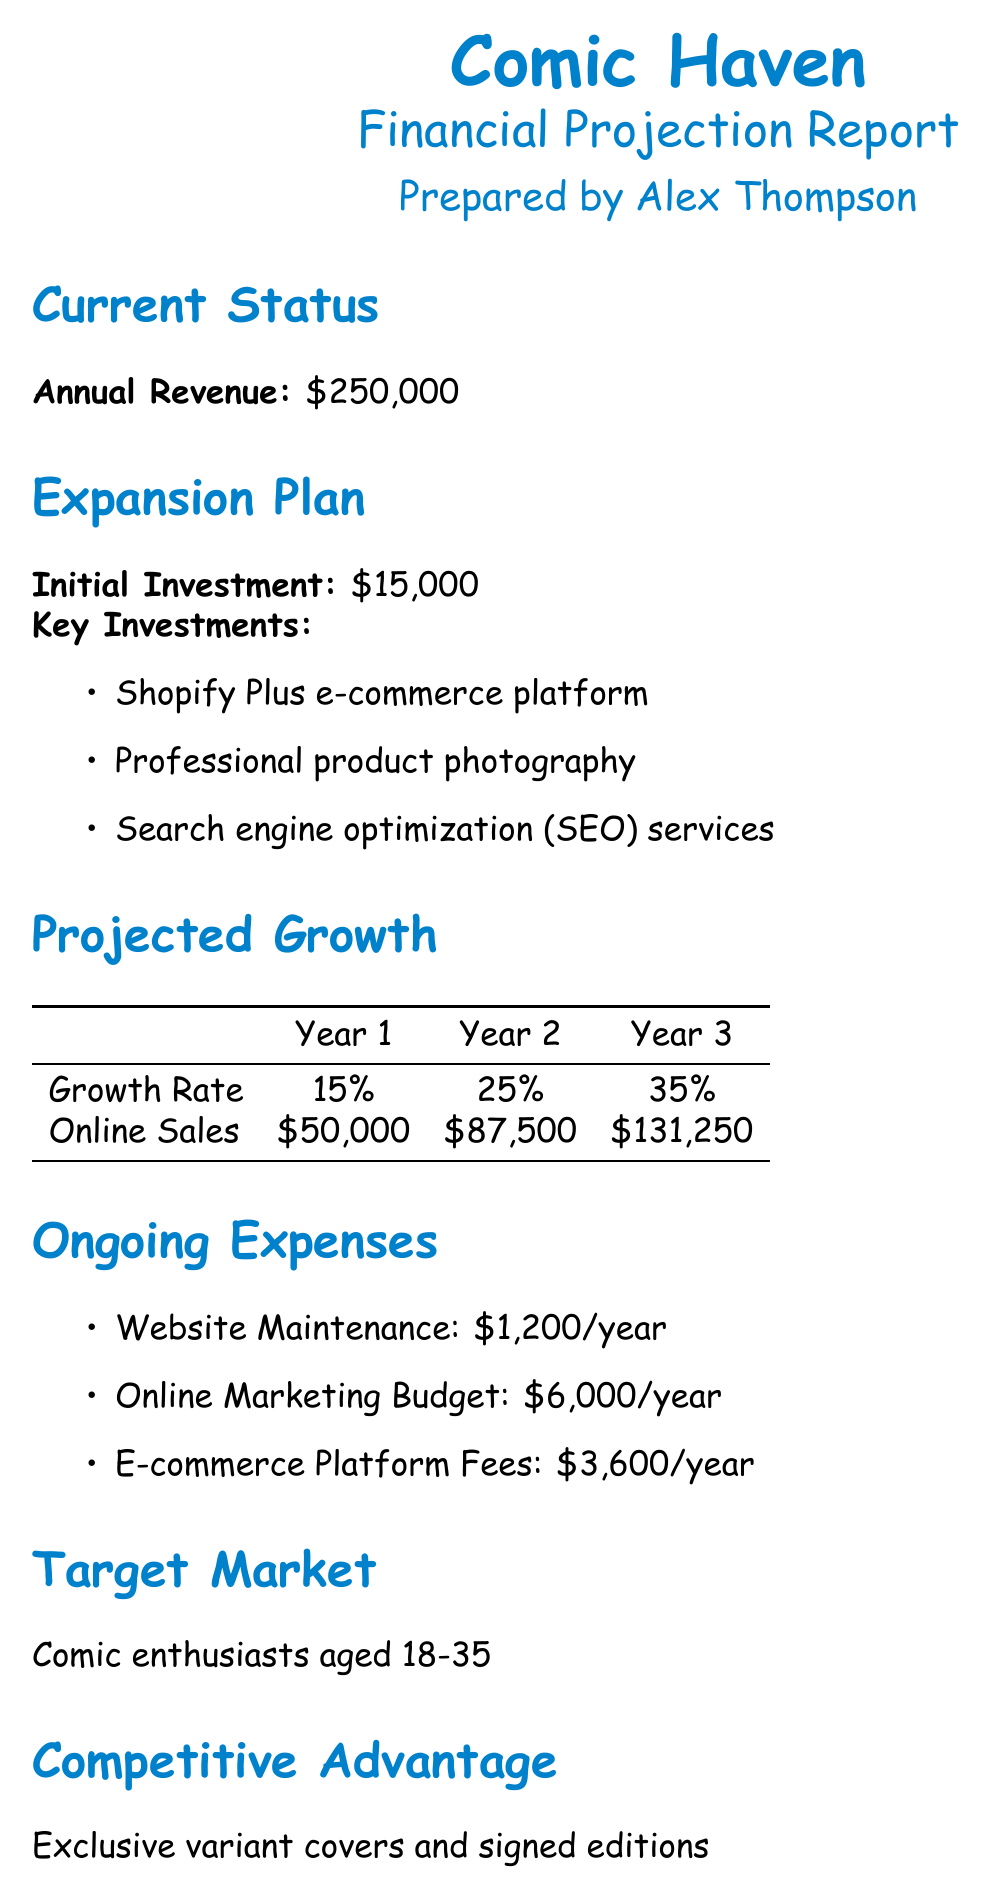What is the current annual revenue? The current annual revenue is specified in the document as $250,000.
Answer: $250,000 What is the initial investment for the expansion plan? The initial investment amount is explicitly stated as $15,000 in the document.
Answer: $15,000 What is the projected online sales for Year 2? The document outlines the projected online sales for Year 2 as $87,500.
Answer: $87,500 What is the key investment for search engine optimization services? The document lists "Search engine optimization (SEO) services" as one of the key investments.
Answer: Search engine optimization (SEO) services What is the expected growth rate in Year 3? The document indicates that the growth rate for Year 3 is 35%.
Answer: 35% What are the ongoing expenses for website maintenance? The ongoing expenses for website maintenance are detailed in the document as $1,200/year.
Answer: $1,200/year What is the target market for Comic Haven? The document specifies that the target market consists of comic enthusiasts aged 18-35.
Answer: Comic enthusiasts aged 18-35 What is the break-even sales volume required? According to the document, the sales volume required to break even is $75,000.
Answer: $75,000 What are the risk factors mentioned? The document outlines risk factors that include increased competition, potential shipping delays, and fluctuations in comic book popularity.
Answer: Increased competition from larger online retailers, Potential shipping delays affecting customer satisfaction, Fluctuations in comic book popularity and trends 